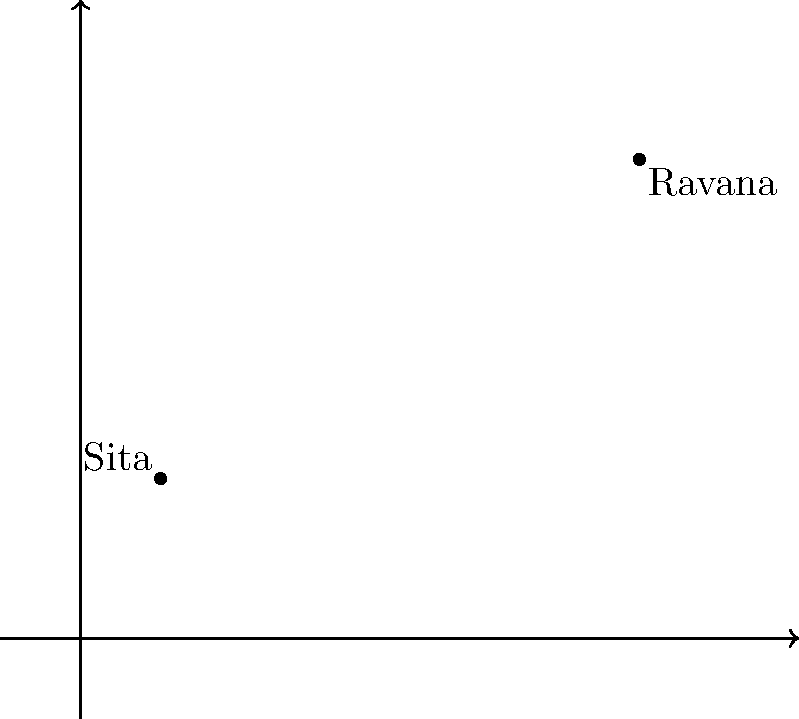In a literary coordinate plane inspired by the Ramayana, Sita is located at point (1, 2) and Ravana at point (7, 6). Calculate the distance between these two characters using the distance formula. Round your answer to two decimal places. To find the distance between two points, we use the distance formula:

$$d = \sqrt{(x_2 - x_1)^2 + (y_2 - y_1)^2}$$

Where $(x_1, y_1)$ represents the coordinates of the first point (Sita) and $(x_2, y_2)$ represents the coordinates of the second point (Ravana).

Step 1: Identify the coordinates
Sita: $(x_1, y_1) = (1, 2)$
Ravana: $(x_2, y_2) = (7, 6)$

Step 2: Substitute the values into the formula
$$d = \sqrt{(7 - 1)^2 + (6 - 2)^2}$$

Step 3: Simplify the expressions inside the parentheses
$$d = \sqrt{6^2 + 4^2}$$

Step 4: Calculate the squares
$$d = \sqrt{36 + 16}$$

Step 5: Add the values under the square root
$$d = \sqrt{52}$$

Step 6: Calculate the square root and round to two decimal places
$$d \approx 7.21$$

Therefore, the distance between Sita and Ravana on the literary coordinate plane is approximately 7.21 units.
Answer: 7.21 units 